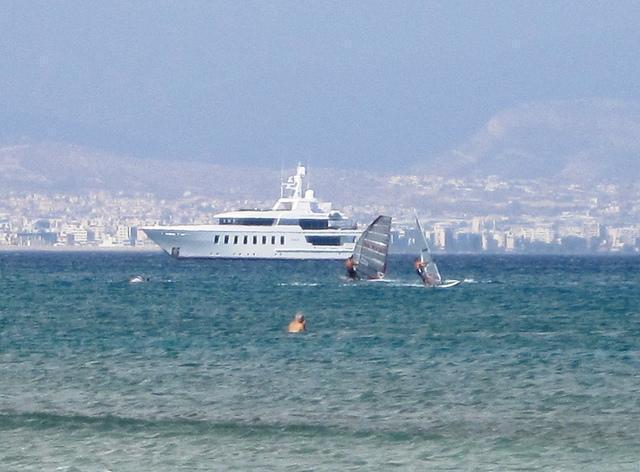How many people are holding onto parasail and sailing into the ocean?
Choose the right answer and clarify with the format: 'Answer: answer
Rationale: rationale.'
Options: Two, four, three, one. Answer: two.
Rationale: The parasails are clearly visible based on the sail and the boards. the riders on the parasails are clearly visible and countable. 